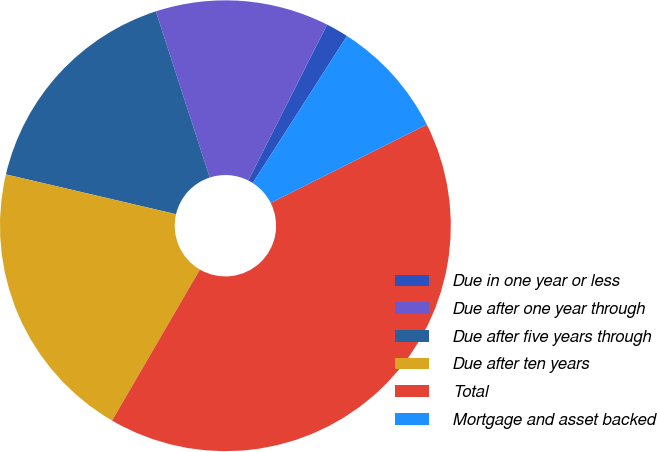Convert chart. <chart><loc_0><loc_0><loc_500><loc_500><pie_chart><fcel>Due in one year or less<fcel>Due after one year through<fcel>Due after five years through<fcel>Due after ten years<fcel>Total<fcel>Mortgage and asset backed<nl><fcel>1.62%<fcel>12.44%<fcel>16.35%<fcel>20.27%<fcel>40.79%<fcel>8.52%<nl></chart> 